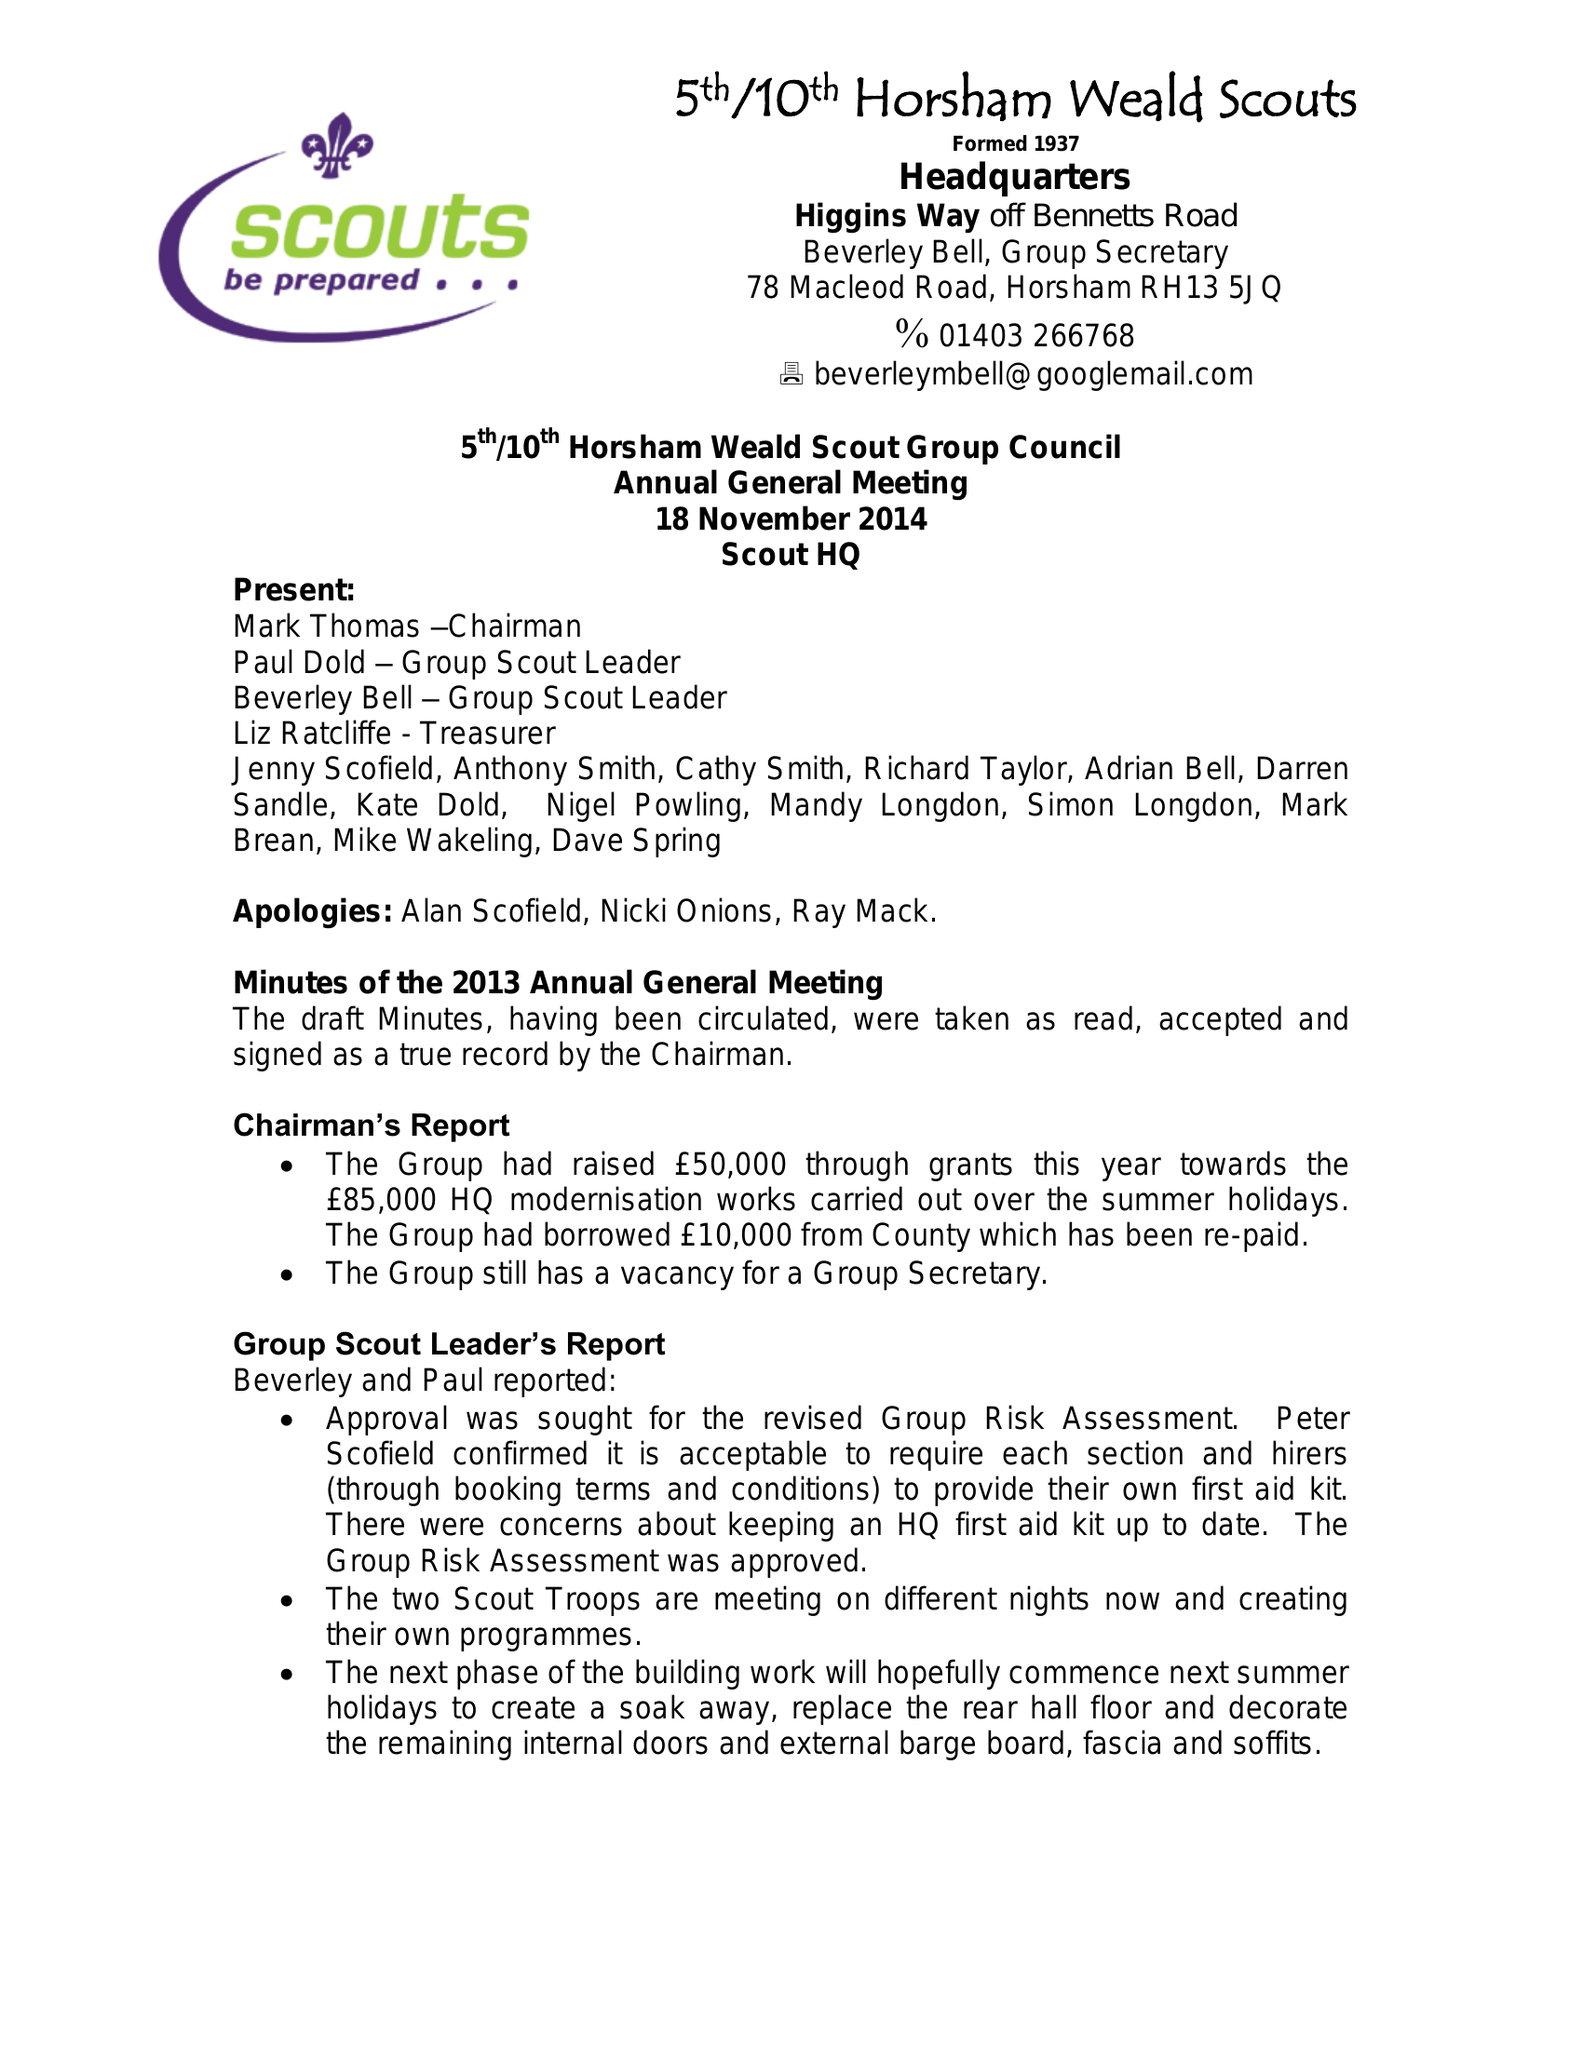What is the value for the report_date?
Answer the question using a single word or phrase. 2014-03-31 